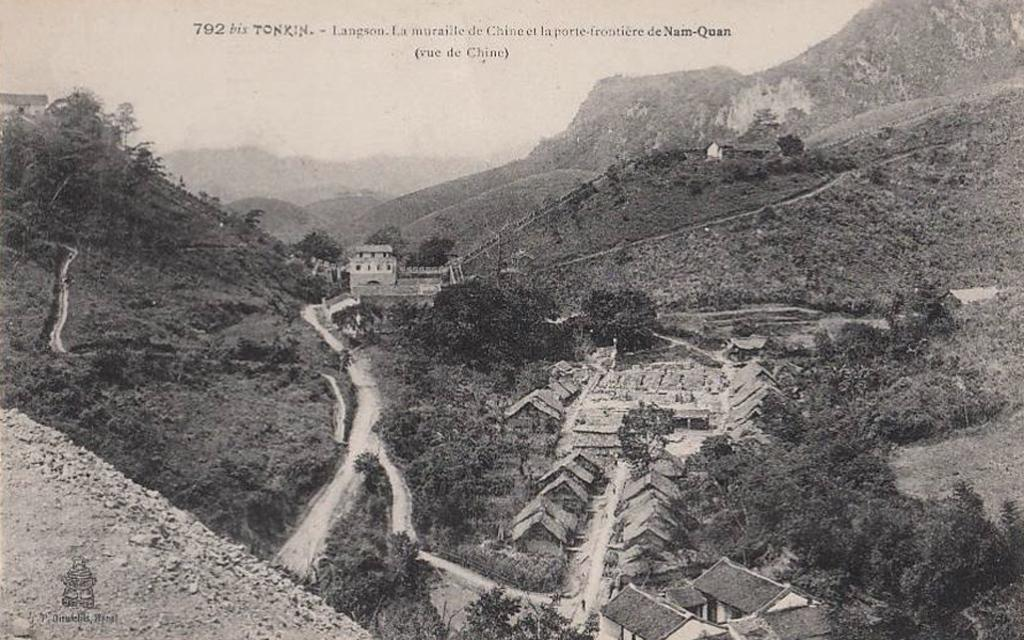What type of picture is in the image? The image contains a black and white picture. What can be seen on the ground in the image? There is ground visible in the image. What type of vegetation is present in the image? There are trees in the image. What type of man-made structure is visible in the image? There is a road and buildings in the image. What type of natural formation is visible in the image? There are mountains in the image. What part of the natural environment is visible in the image? The sky is visible in the image. What type of fan is visible in the image? There is no fan present in the image. What type of secretary can be seen working in the image? There is no secretary present in the image. 